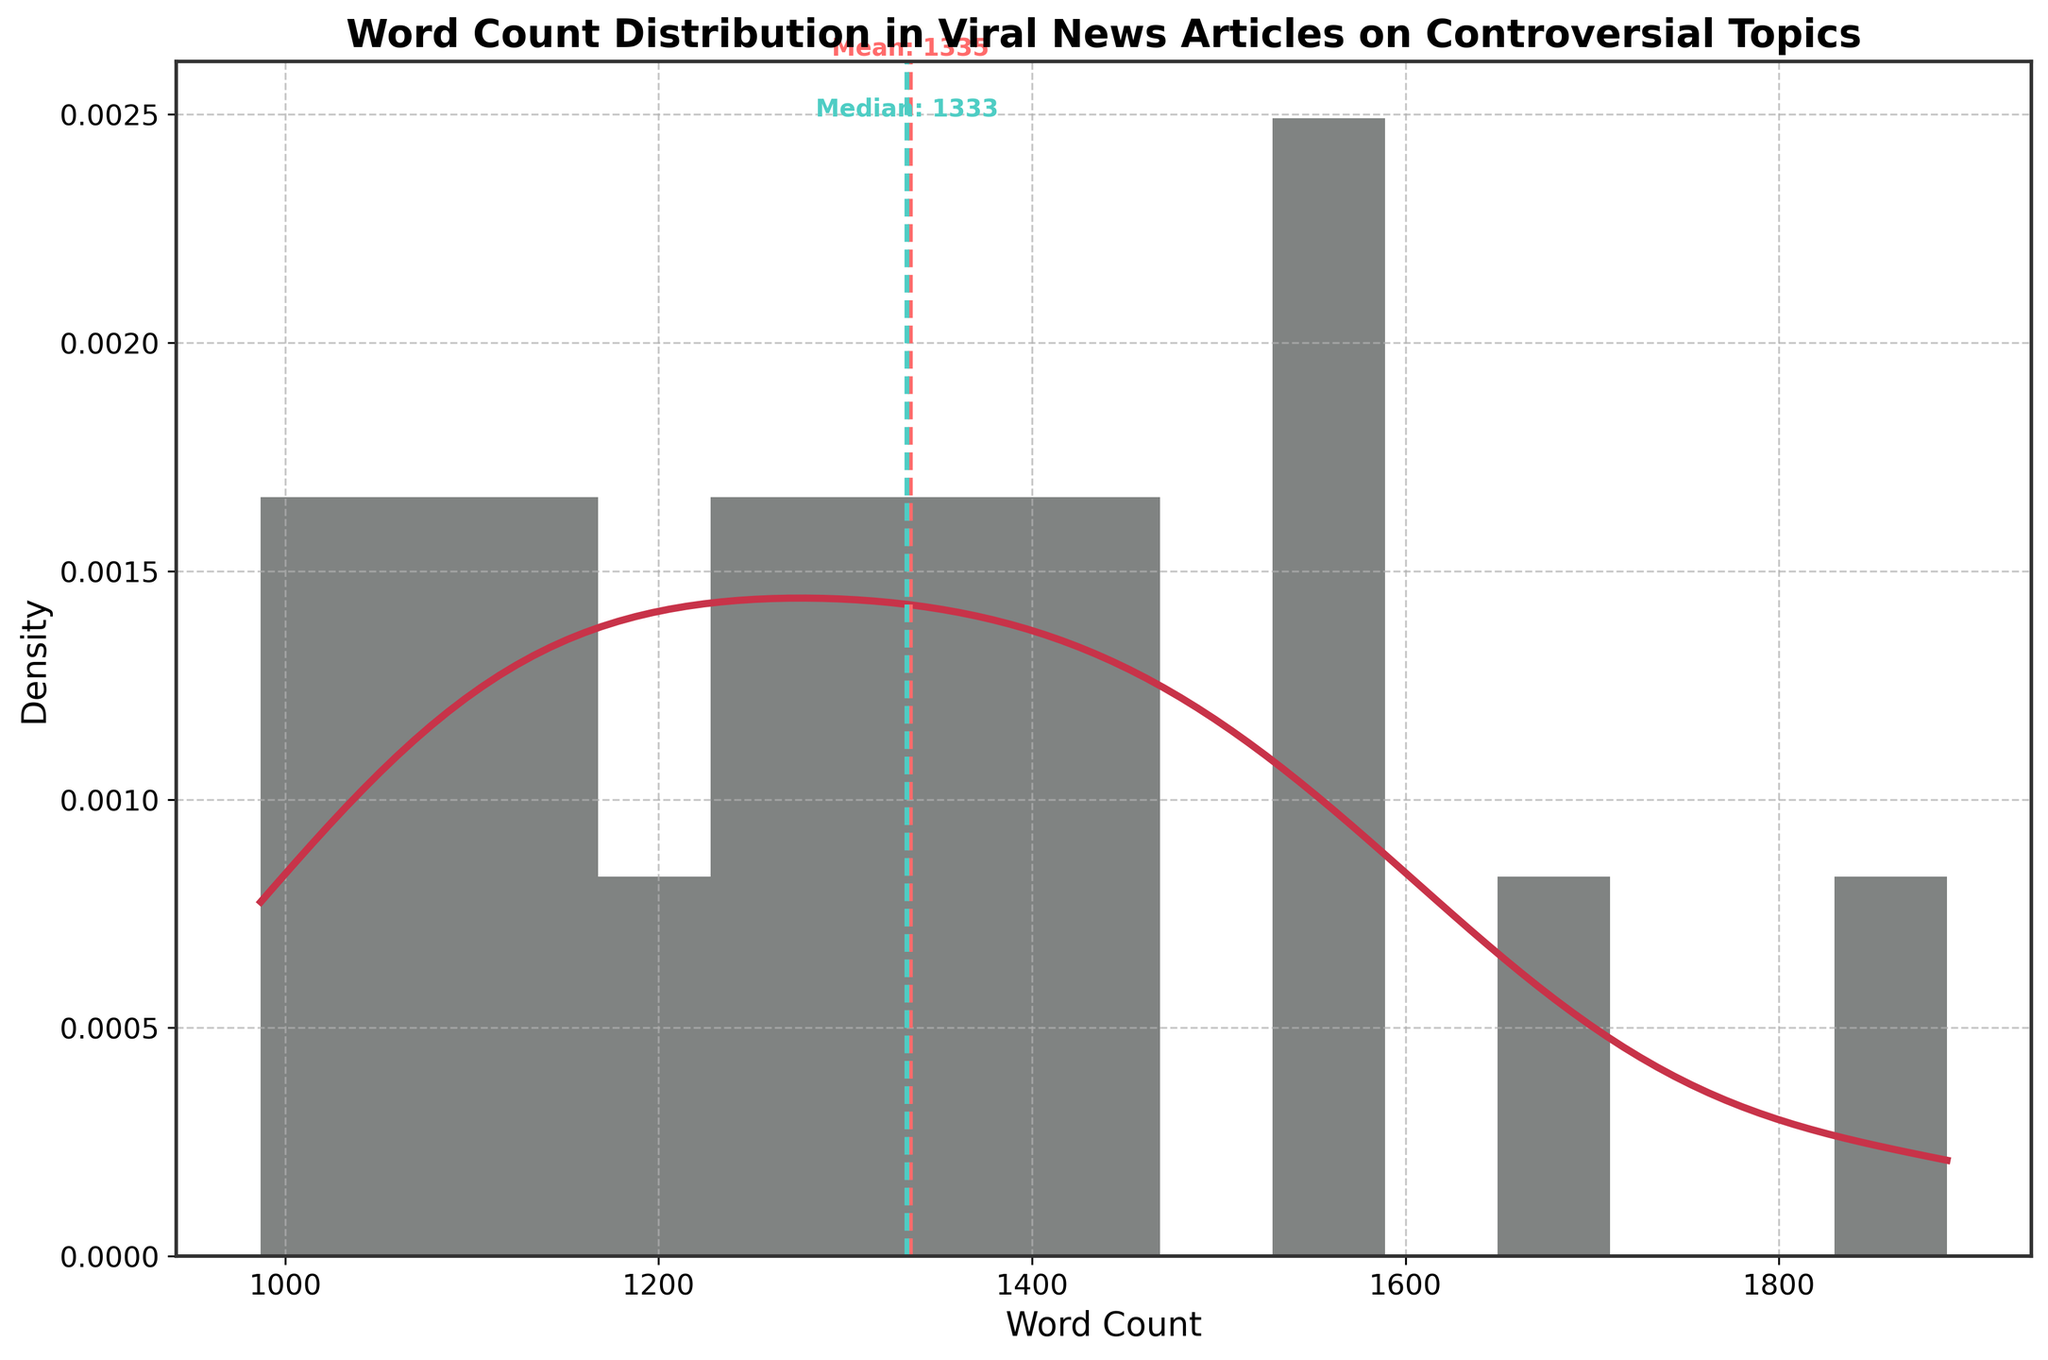What's the title of the chart? The title of the chart is usually prominently displayed at the top of the figure. Here, we can see the title text at the top of the histogram.
Answer: Word Count Distribution in Viral News Articles on Controversial Topics What does the x-axis represent? The x-axis label can be found along the horizontal axis of the chart. It explains what is being measured. In this figure, you can find the label beneath the x-axis.
Answer: Word Count What does the y-axis represent? The y-axis label is typically located along the vertical axis. It tells us what the values/measurements along the y-axis are. In this figure, the label is adjacent to the y-axis.
Answer: Density What do the dashed lines in the figure indicate? The two dashed lines represent statistical measures in the data. The colors differentiate them and the annotations alongside the lines provide further cues. The red dashed line indicates the mean, and the teal dashed line indicates the median.
Answer: Mean and Median What is the mean word count of the news articles? The mean word count is depicted by the red dashed line and is annotated next to the line. The value can be directly read from the figure.
Answer: 1327 What is the median word count of the news articles? The median word count is shown by the teal dashed line and is annotated next to the line. The value can be directly read from the figure.
Answer: 1345 What word count has the highest density in the distribution? The highest density peak on the KDE curve tells us where most data points are. We need to find the x-value corresponding to this peak on the red curve.
Answer: Around 1350 How many bins are used in the histogram? The histogram bins can be counted directly from the histogram bars in the chart. Each bar represents one bin.
Answer: 15 Which has the higher word count, the mean or the median? By comparing the positions of the dashed lines indicating the mean and median, we can determine which is higher. Here, the median (teal line) is slightly higher than the mean (red line).
Answer: Median Is the distribution of word count symmetric? Symmetry in a distribution can be assessed by comparing the shape and spread of the histogram and KDE curve on both sides of the center. If they are approximately the same, the distribution is symmetric. Here, the data looks slightly skewed.
Answer: No 